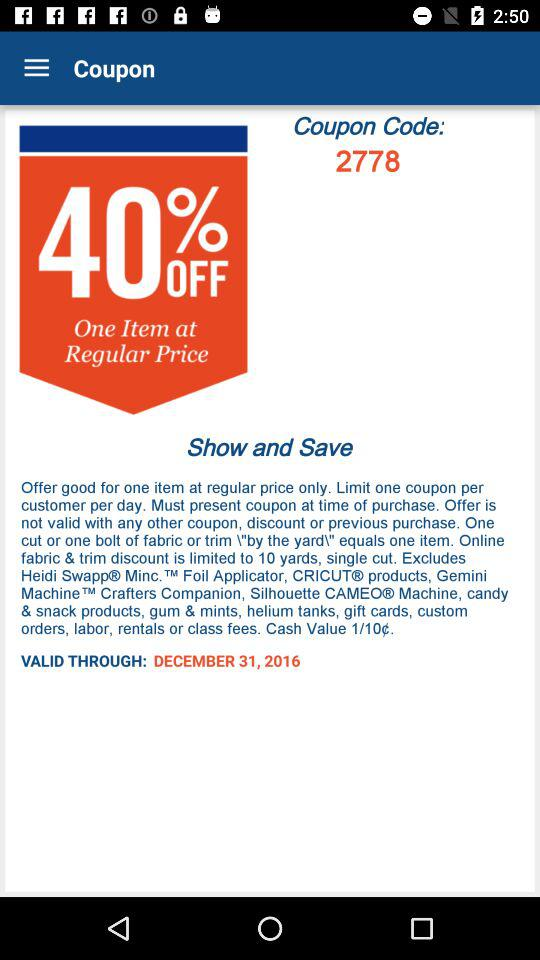How much discount will be available on using the coupon code? The available discount will be 40%. 